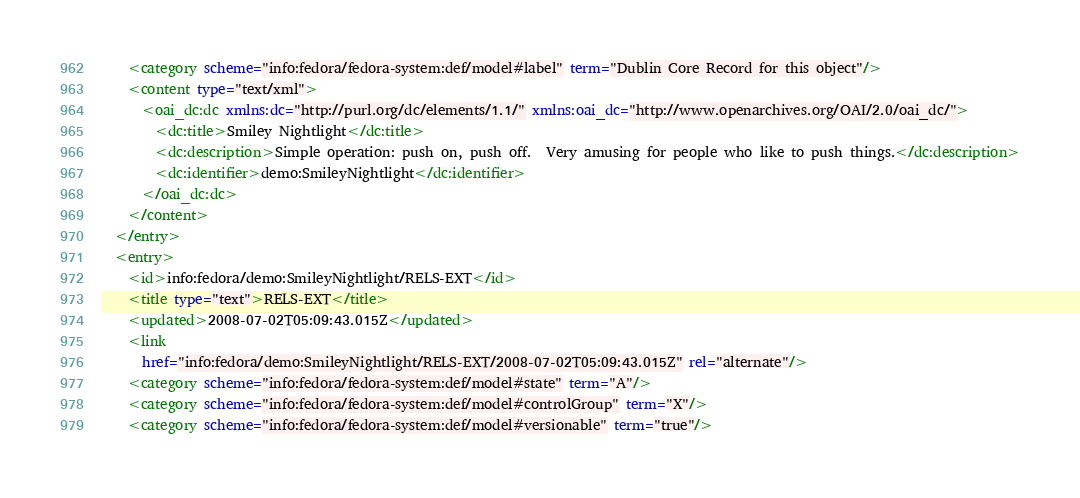<code> <loc_0><loc_0><loc_500><loc_500><_XML_>    <category scheme="info:fedora/fedora-system:def/model#label" term="Dublin Core Record for this object"/>
    <content type="text/xml">
      <oai_dc:dc xmlns:dc="http://purl.org/dc/elements/1.1/" xmlns:oai_dc="http://www.openarchives.org/OAI/2.0/oai_dc/">
        <dc:title>Smiley Nightlight</dc:title>
        <dc:description>Simple operation: push on, push off.  Very amusing for people who like to push things.</dc:description>
        <dc:identifier>demo:SmileyNightlight</dc:identifier>
      </oai_dc:dc>
    </content>
  </entry>
  <entry>
    <id>info:fedora/demo:SmileyNightlight/RELS-EXT</id>
    <title type="text">RELS-EXT</title>
    <updated>2008-07-02T05:09:43.015Z</updated>
    <link
      href="info:fedora/demo:SmileyNightlight/RELS-EXT/2008-07-02T05:09:43.015Z" rel="alternate"/>
    <category scheme="info:fedora/fedora-system:def/model#state" term="A"/>
    <category scheme="info:fedora/fedora-system:def/model#controlGroup" term="X"/>
    <category scheme="info:fedora/fedora-system:def/model#versionable" term="true"/></code> 